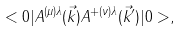<formula> <loc_0><loc_0><loc_500><loc_500>< 0 | A ^ { ( \mu ) \lambda } ( \vec { k } ) A ^ { + ( \nu ) \lambda } ( \vec { k } ^ { \prime } ) | 0 > ,</formula> 